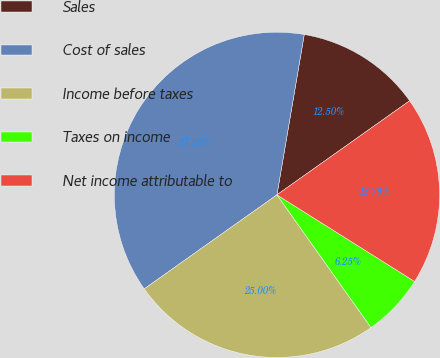Convert chart. <chart><loc_0><loc_0><loc_500><loc_500><pie_chart><fcel>Sales<fcel>Cost of sales<fcel>Income before taxes<fcel>Taxes on income<fcel>Net income attributable to<nl><fcel>12.5%<fcel>37.5%<fcel>25.0%<fcel>6.25%<fcel>18.75%<nl></chart> 